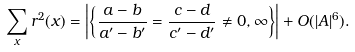<formula> <loc_0><loc_0><loc_500><loc_500>\sum _ { x } r ^ { 2 } ( x ) = \left | \left \{ \frac { a - b } { a ^ { \prime } - b ^ { \prime } } = \frac { c - d } { c ^ { \prime } - d ^ { \prime } } \not = 0 , \infty \right \} \right | + O ( | A | ^ { 6 } ) .</formula> 